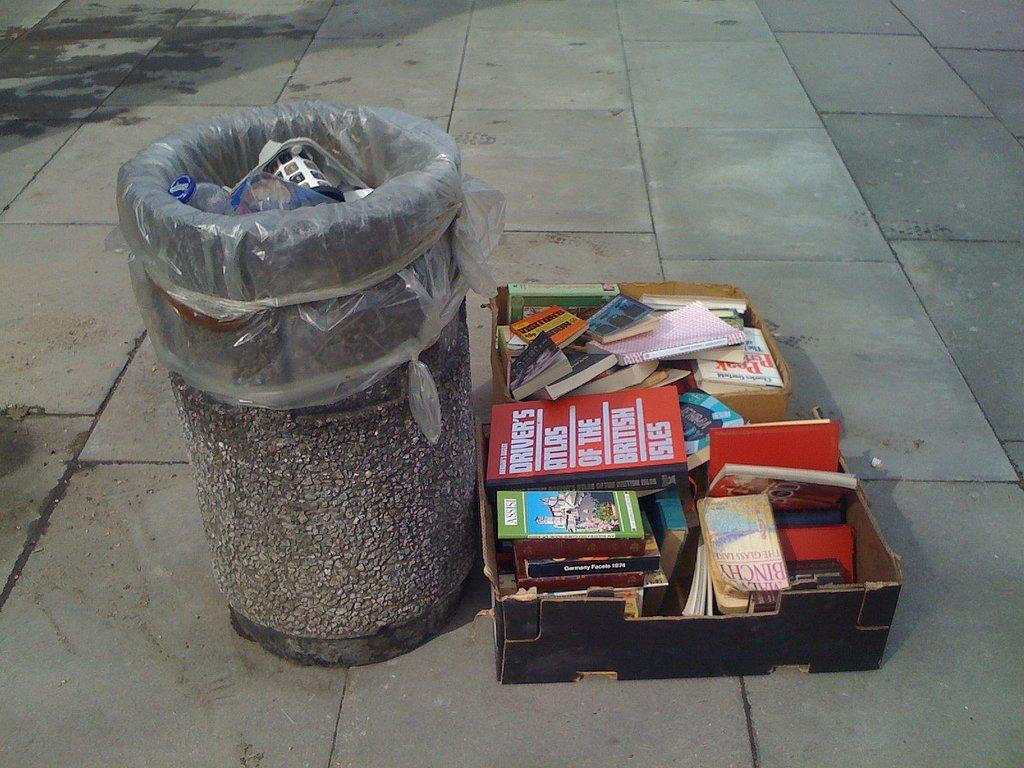<image>
Create a compact narrative representing the image presented. The Driver's Atlas of the British Isles sits atop a box of books sitting beside the trash can. 